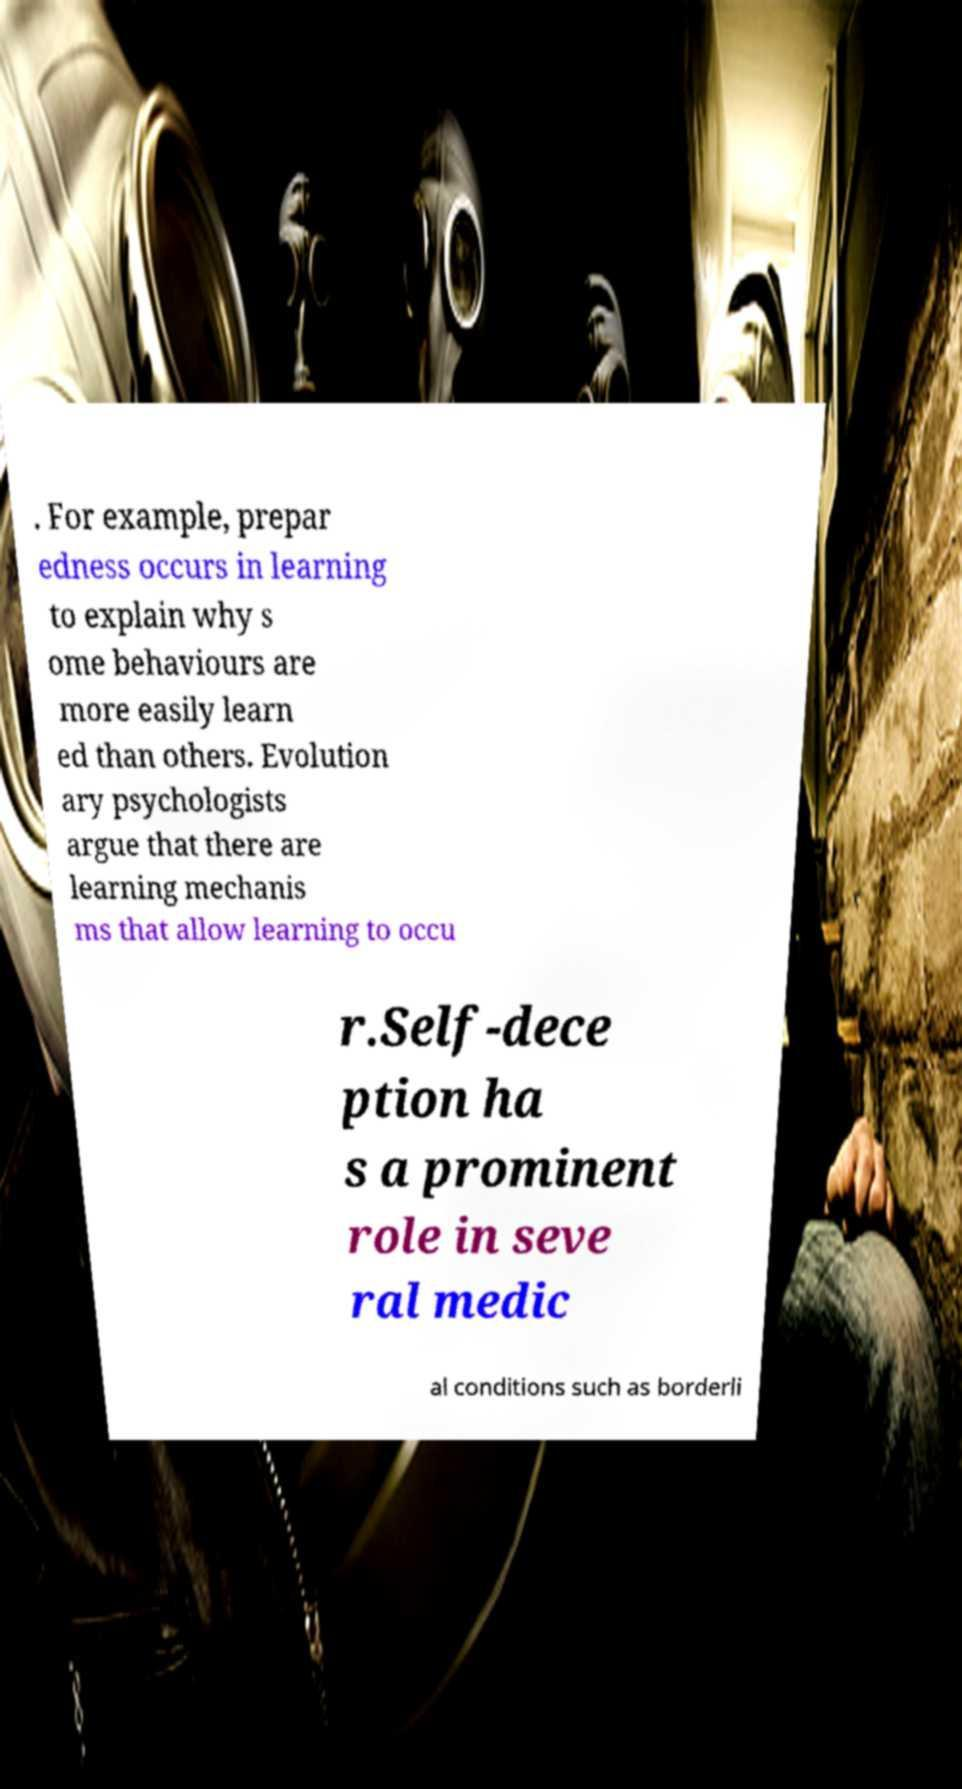Please identify and transcribe the text found in this image. . For example, prepar edness occurs in learning to explain why s ome behaviours are more easily learn ed than others. Evolution ary psychologists argue that there are learning mechanis ms that allow learning to occu r.Self-dece ption ha s a prominent role in seve ral medic al conditions such as borderli 